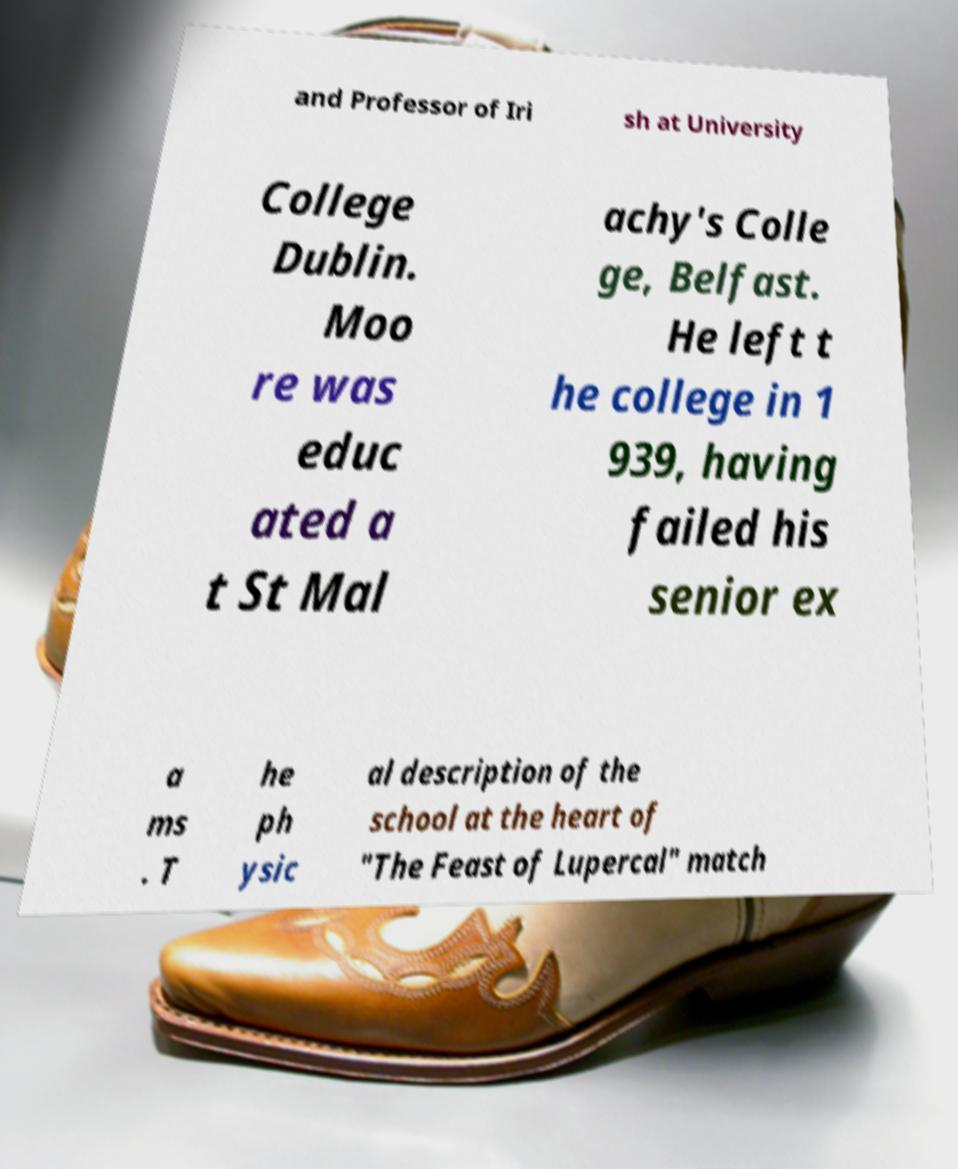Can you accurately transcribe the text from the provided image for me? and Professor of Iri sh at University College Dublin. Moo re was educ ated a t St Mal achy's Colle ge, Belfast. He left t he college in 1 939, having failed his senior ex a ms . T he ph ysic al description of the school at the heart of "The Feast of Lupercal" match 